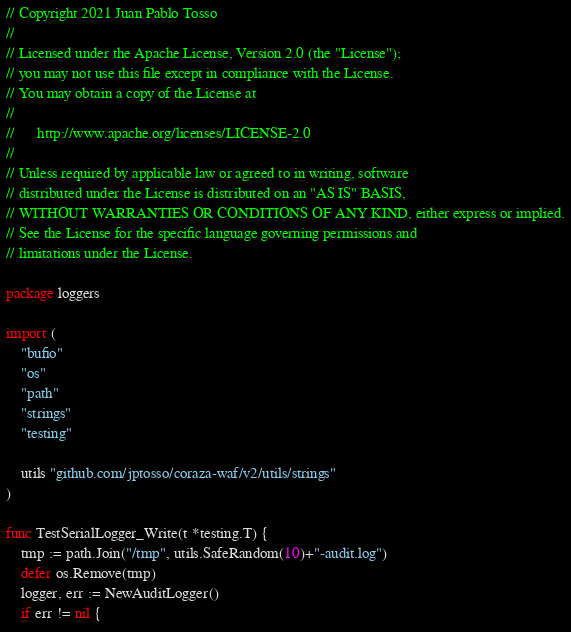Convert code to text. <code><loc_0><loc_0><loc_500><loc_500><_Go_>// Copyright 2021 Juan Pablo Tosso
//
// Licensed under the Apache License, Version 2.0 (the "License");
// you may not use this file except in compliance with the License.
// You may obtain a copy of the License at
//
//      http://www.apache.org/licenses/LICENSE-2.0
//
// Unless required by applicable law or agreed to in writing, software
// distributed under the License is distributed on an "AS IS" BASIS,
// WITHOUT WARRANTIES OR CONDITIONS OF ANY KIND, either express or implied.
// See the License for the specific language governing permissions and
// limitations under the License.

package loggers

import (
	"bufio"
	"os"
	"path"
	"strings"
	"testing"

	utils "github.com/jptosso/coraza-waf/v2/utils/strings"
)

func TestSerialLogger_Write(t *testing.T) {
	tmp := path.Join("/tmp", utils.SafeRandom(10)+"-audit.log")
	defer os.Remove(tmp)
	logger, err := NewAuditLogger()
	if err != nil {</code> 